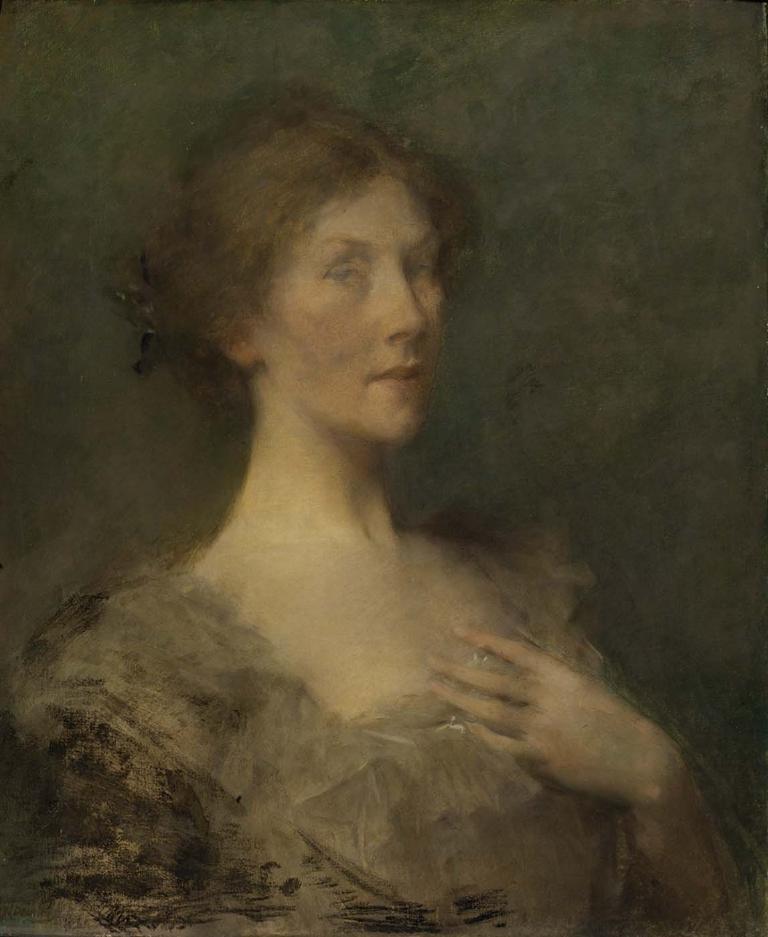Describe this image in one or two sentences. In this image I see a painting of a woman and it is black on the sides. 